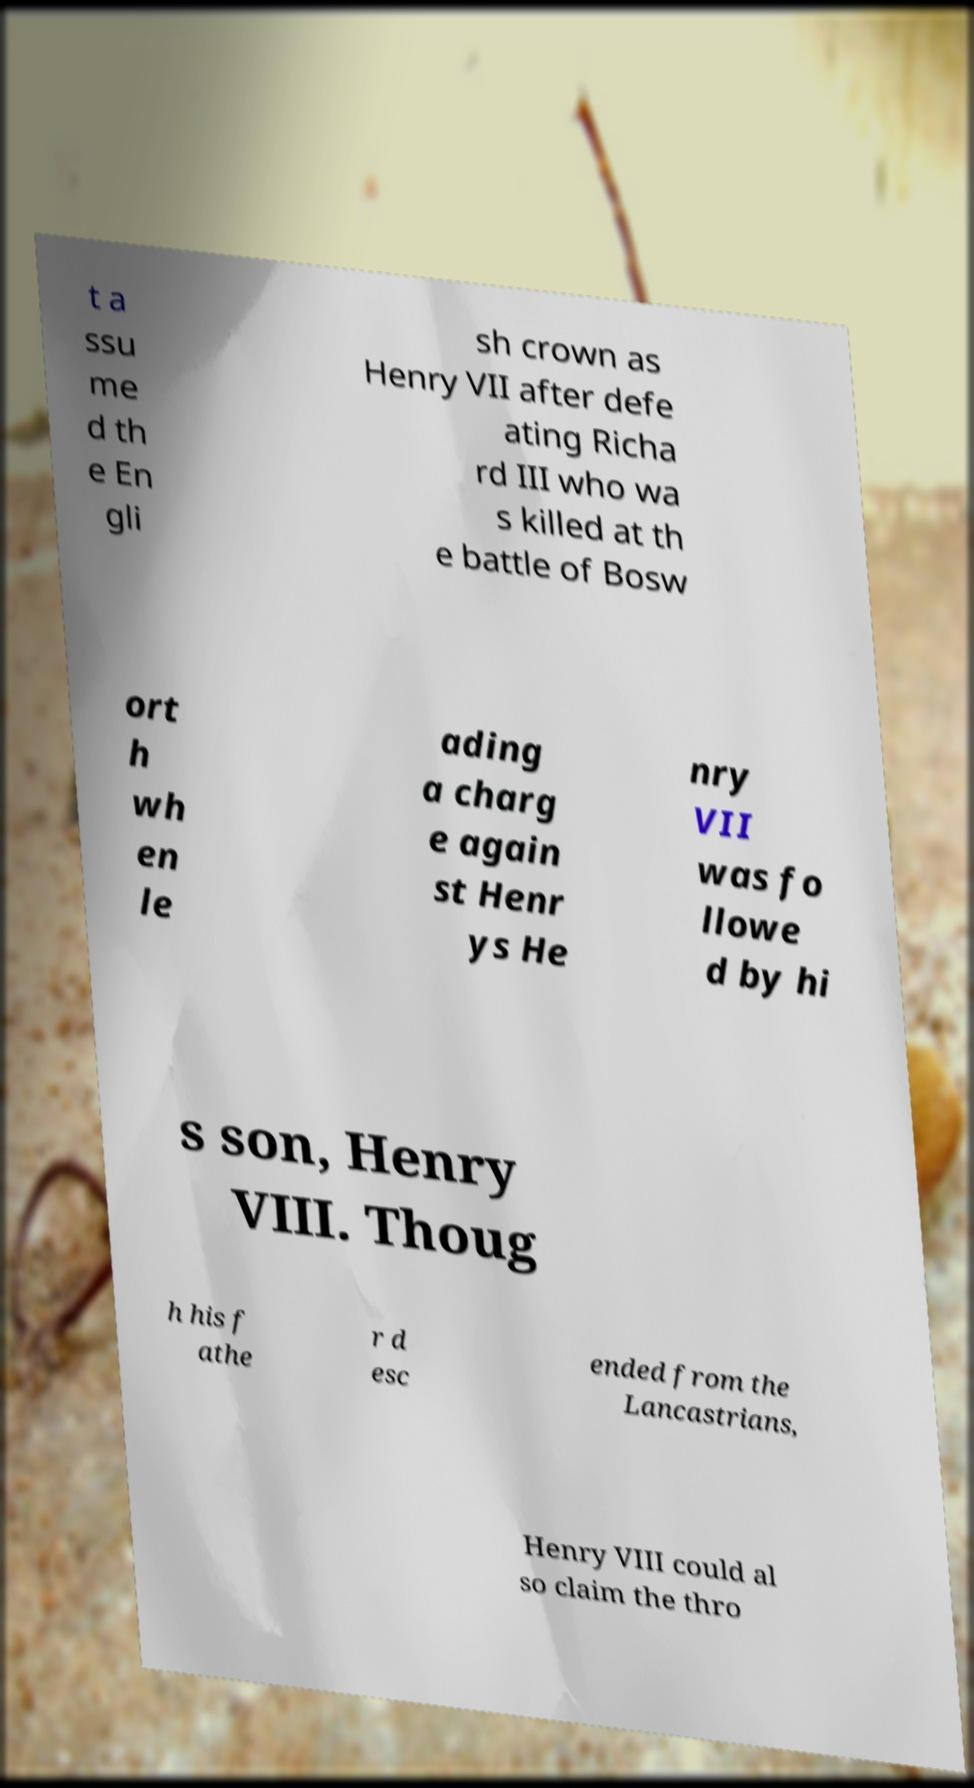Can you read and provide the text displayed in the image?This photo seems to have some interesting text. Can you extract and type it out for me? t a ssu me d th e En gli sh crown as Henry VII after defe ating Richa rd III who wa s killed at th e battle of Bosw ort h wh en le ading a charg e again st Henr ys He nry VII was fo llowe d by hi s son, Henry VIII. Thoug h his f athe r d esc ended from the Lancastrians, Henry VIII could al so claim the thro 